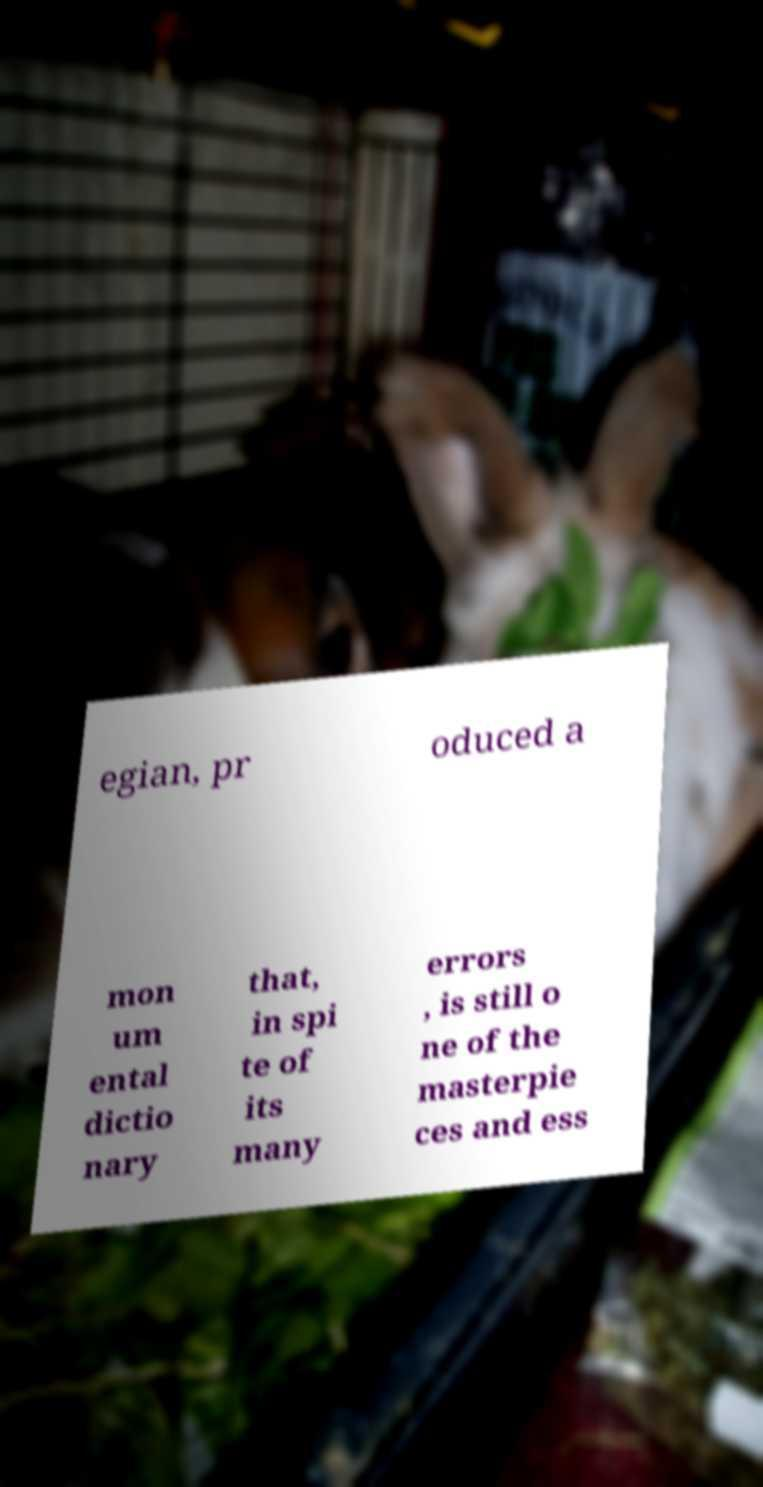Can you accurately transcribe the text from the provided image for me? egian, pr oduced a mon um ental dictio nary that, in spi te of its many errors , is still o ne of the masterpie ces and ess 